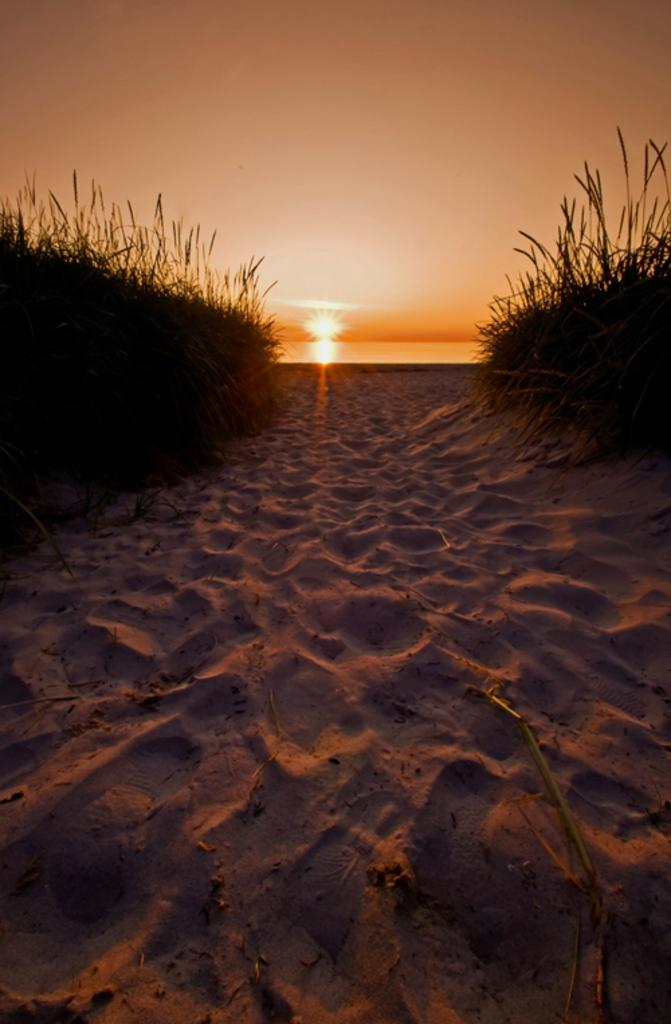What type of terrain is visible in the image? There is sand and grass visible in the image. What celestial body can be seen in the background of the image? The sun is visible in the background of the image. What else can be seen in the background of the image? The sky is visible in the background of the image. How many rings are stacked on the pencil in the image? There are no rings or pencils present in the image. 